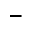<formula> <loc_0><loc_0><loc_500><loc_500>-</formula> 